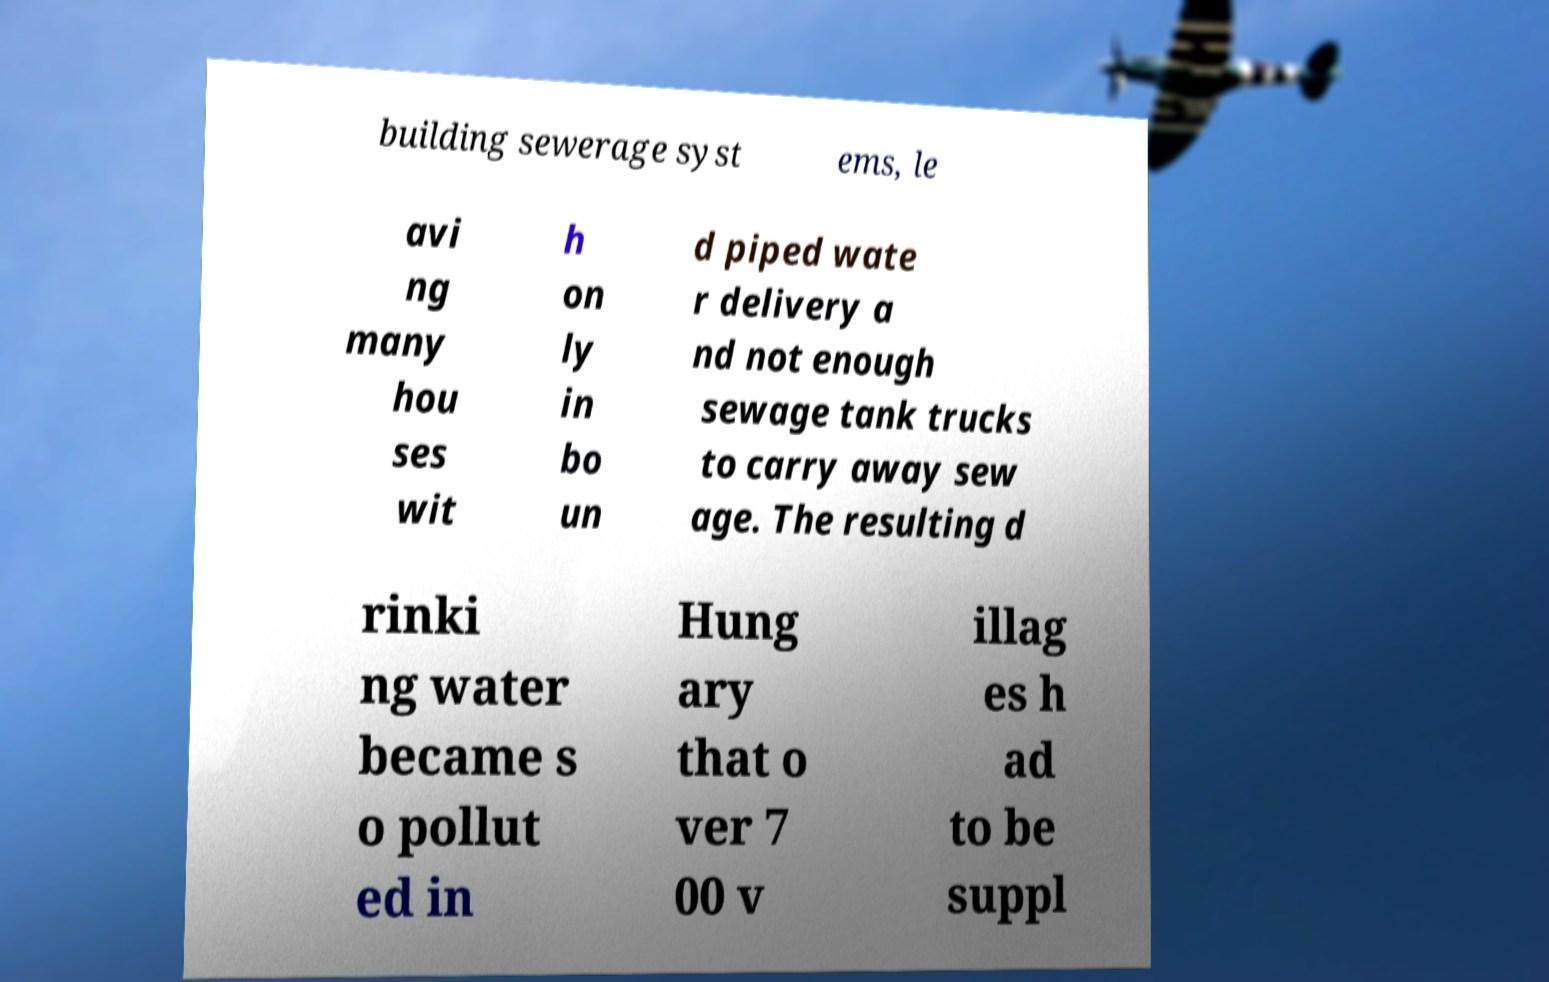Please read and relay the text visible in this image. What does it say? building sewerage syst ems, le avi ng many hou ses wit h on ly in bo un d piped wate r delivery a nd not enough sewage tank trucks to carry away sew age. The resulting d rinki ng water became s o pollut ed in Hung ary that o ver 7 00 v illag es h ad to be suppl 